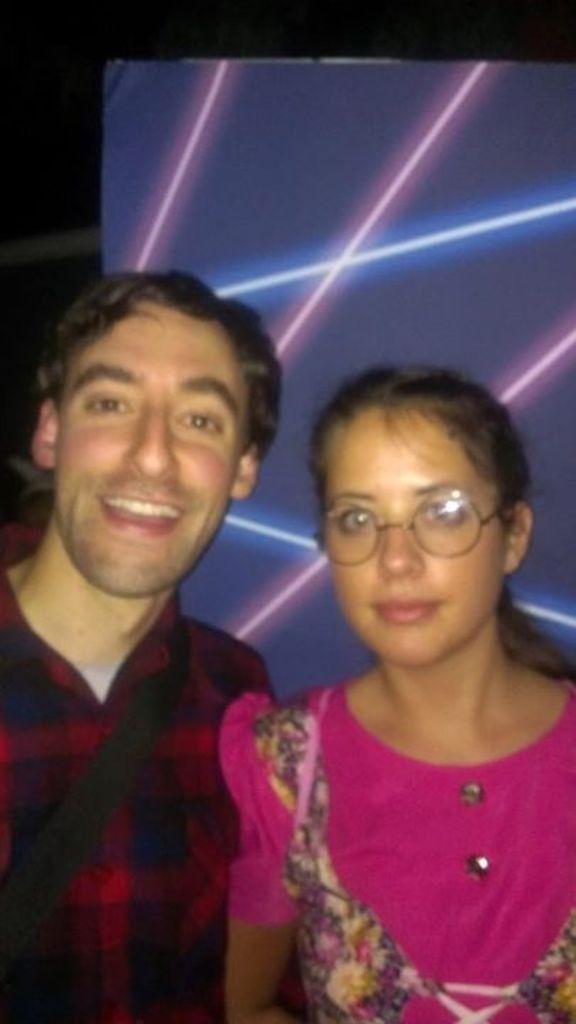Describe this image in one or two sentences. In this image there is a man and a woman, in the background there are lights. 